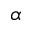Convert formula to latex. <formula><loc_0><loc_0><loc_500><loc_500>\alpha</formula> 